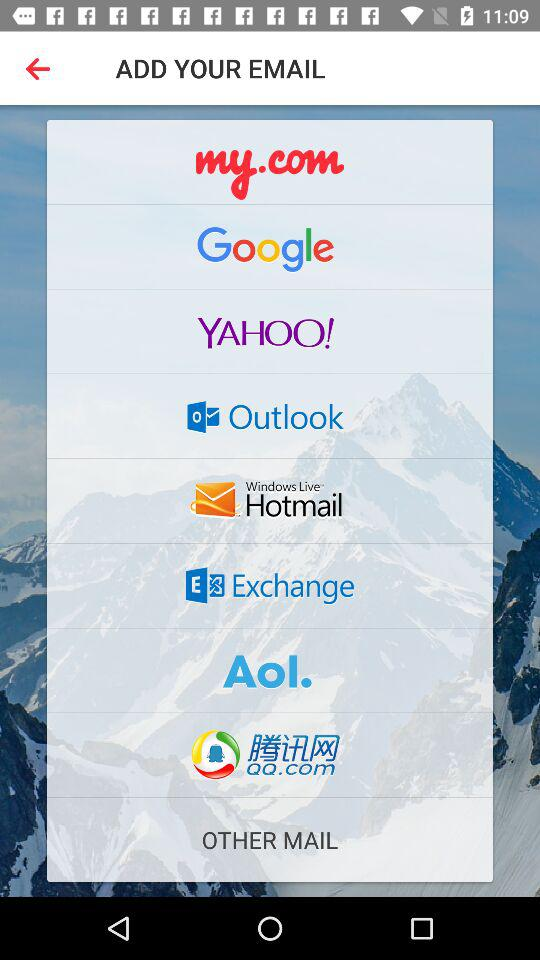Where can we add our email address? You can add your email address at "my.com", "Google", "YAHOO!", "Outlook", "Windows Live Hotmail", "Exchange", "AoI." and "QQ.com". 